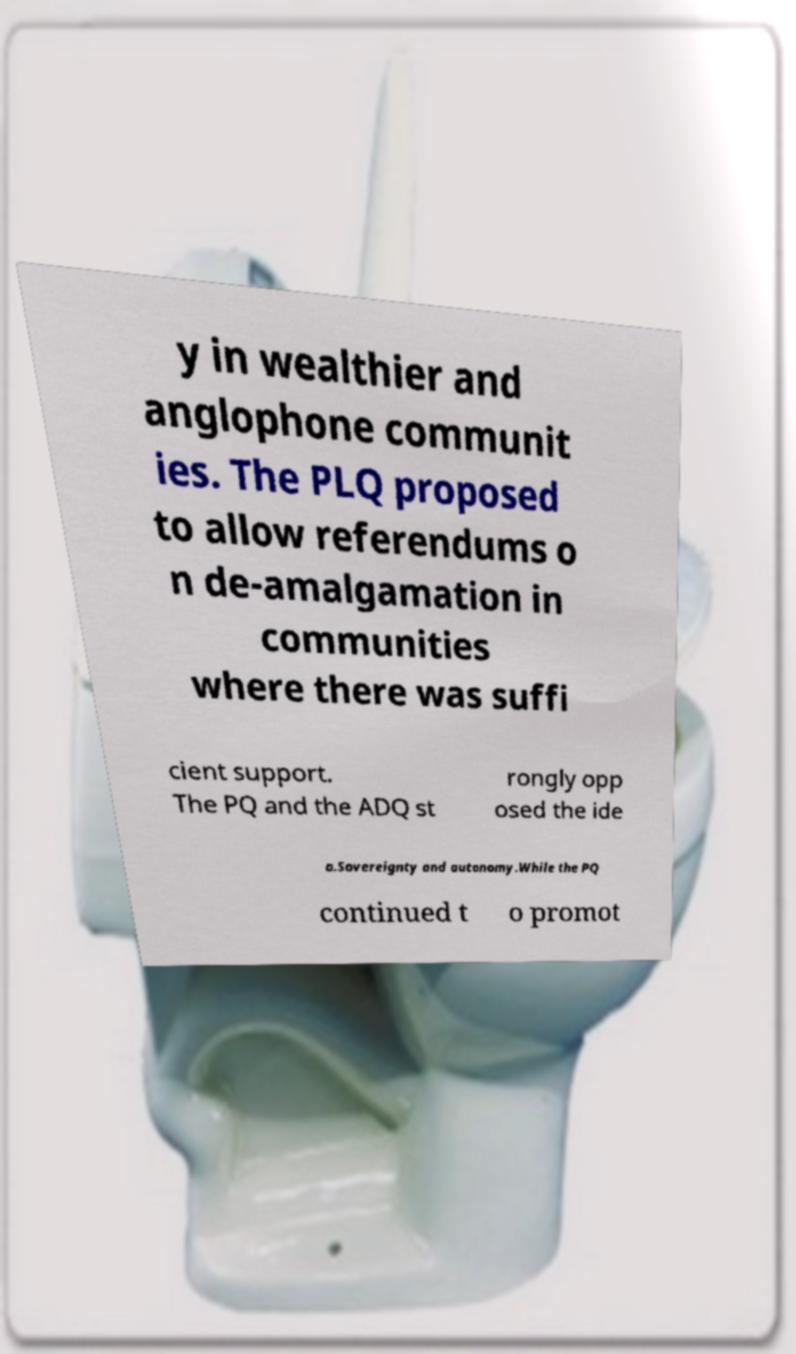Can you read and provide the text displayed in the image?This photo seems to have some interesting text. Can you extract and type it out for me? y in wealthier and anglophone communit ies. The PLQ proposed to allow referendums o n de-amalgamation in communities where there was suffi cient support. The PQ and the ADQ st rongly opp osed the ide a.Sovereignty and autonomy.While the PQ continued t o promot 